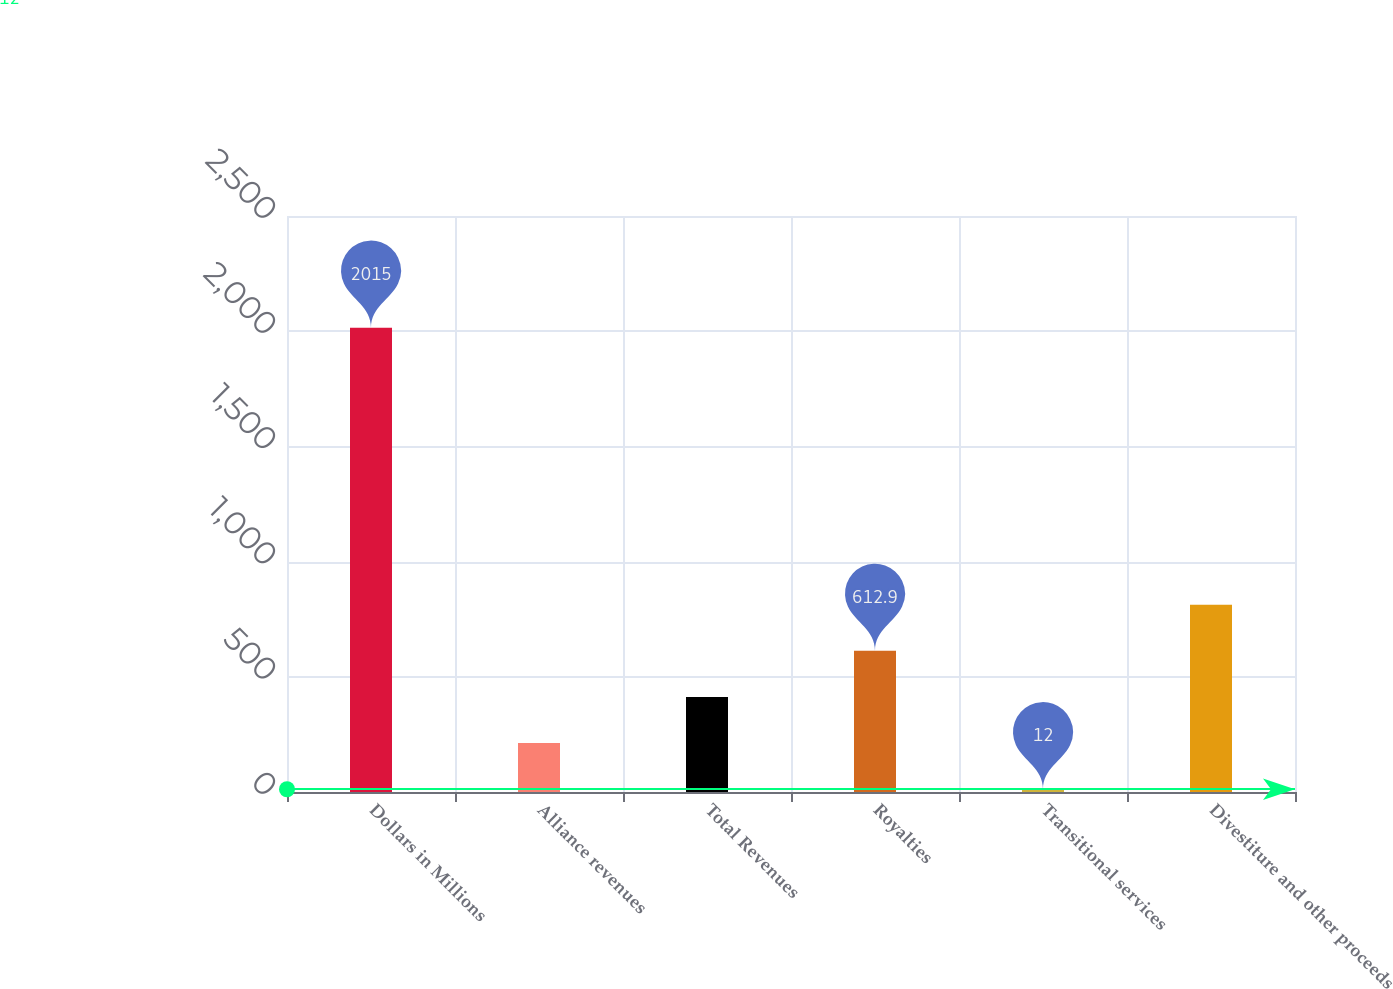Convert chart to OTSL. <chart><loc_0><loc_0><loc_500><loc_500><bar_chart><fcel>Dollars in Millions<fcel>Alliance revenues<fcel>Total Revenues<fcel>Royalties<fcel>Transitional services<fcel>Divestiture and other proceeds<nl><fcel>2015<fcel>212.3<fcel>412.6<fcel>612.9<fcel>12<fcel>813.2<nl></chart> 